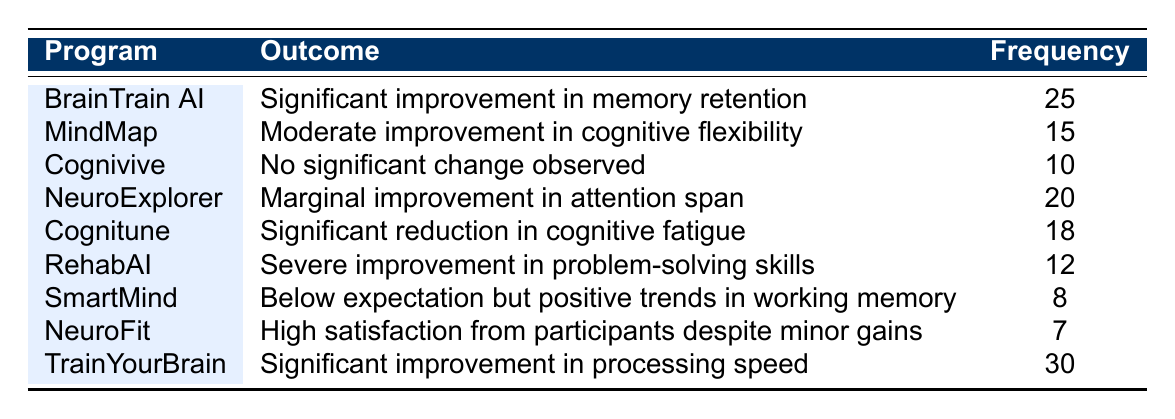What is the most common reported outcome among the AI-assisted cognitive rehabilitation programs? The most common reported outcome can be identified by looking for the highest frequency value in the table. The program "TrainYourBrain" has the highest frequency of 30.
Answer: Significant improvement in processing speed Which program reported a significant reduction in cognitive fatigue? By scanning the outcomes listed for each program, "Cognitune" specifically mentions a significant reduction in cognitive fatigue.
Answer: Cognitune How many programs reported outcomes that indicate a form of improvement? To find the total number of programs reporting some form of improvement, count the programs with outcomes like significant, moderate, or marginal improvement. The programs "BrainTrain AI," "MindMap," "NeuroExplorer," "Cognitune," and "TrainYourBrain" show improvement, totaling 5 programs.
Answer: 5 Is there a program that reported a severe improvement in any cognitive skill? By looking for the term "severe improvement" in the outcomes, it can be seen that "RehabAI" reported severe improvement in problem-solving skills.
Answer: Yes What is the average frequency of improvement outcomes across all listed programs? To calculate the average frequency, first identify the frequency values of the programs reporting improvements: 25, 15, 20, 18, and 30. The sum of these frequencies is 25 + 15 + 20 + 18 + 30 = 108. Since there are 5 programs, the average is 108 divided by 5, which equals 21.6.
Answer: 21.6 Which program had the lowest frequency and what was its outcome? Scan the frequency column and identify the program with the lowest frequency value. "NeuroFit" has the lowest frequency of 7 and the corresponding outcome is "High satisfaction from participants despite minor gains."
Answer: NeuroFit, High satisfaction from participants despite minor gains How many reported outcomes mentioned no significant change? Check the outcomes to see which programs indicated "no significant change." Only "Cognivive" mentions no significant change observed, resulting in a total of 1 program with this outcome.
Answer: 1 What is the difference in frequency between the highest and lowest reported cognitive outcomes? The highest frequency is 30 (TrainYourBrain), and the lowest is 7 (NeuroFit). To find the difference, subtract the lowest from the highest: 30 - 7 = 23.
Answer: 23 